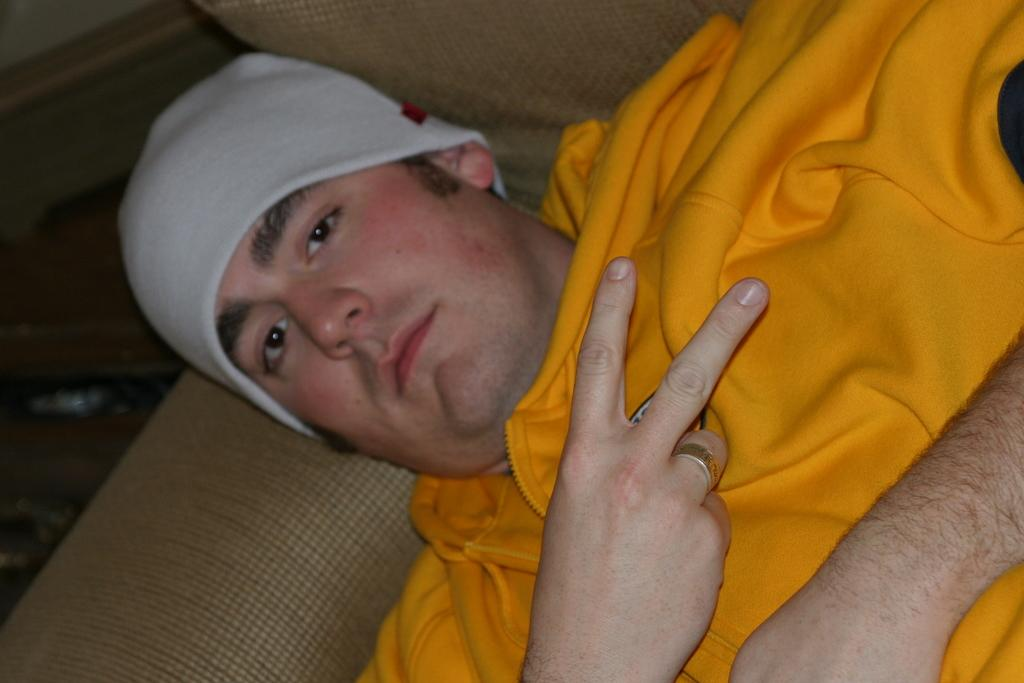Who is present in the image? There is a person in the image. What is the person doing in the image? The person is on a sofa. What is the person wearing in the image? The person is wearing a yellow jacket and a cap. What else can be seen on the floor in the image? There is a bag on the floor. Can you see any ants crawling on the person's yellow jacket in the image? There are no ants visible in the image, and therefore none can be seen crawling on the person's yellow jacket. 